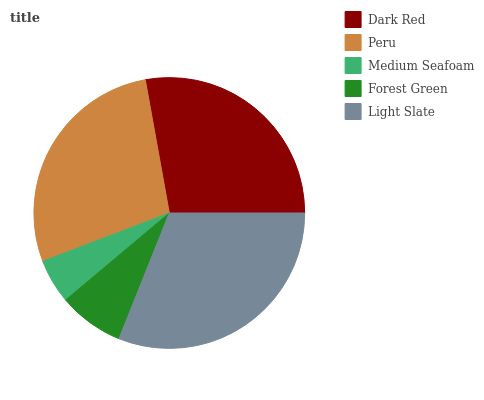Is Medium Seafoam the minimum?
Answer yes or no. Yes. Is Light Slate the maximum?
Answer yes or no. Yes. Is Peru the minimum?
Answer yes or no. No. Is Peru the maximum?
Answer yes or no. No. Is Peru greater than Dark Red?
Answer yes or no. Yes. Is Dark Red less than Peru?
Answer yes or no. Yes. Is Dark Red greater than Peru?
Answer yes or no. No. Is Peru less than Dark Red?
Answer yes or no. No. Is Dark Red the high median?
Answer yes or no. Yes. Is Dark Red the low median?
Answer yes or no. Yes. Is Medium Seafoam the high median?
Answer yes or no. No. Is Light Slate the low median?
Answer yes or no. No. 